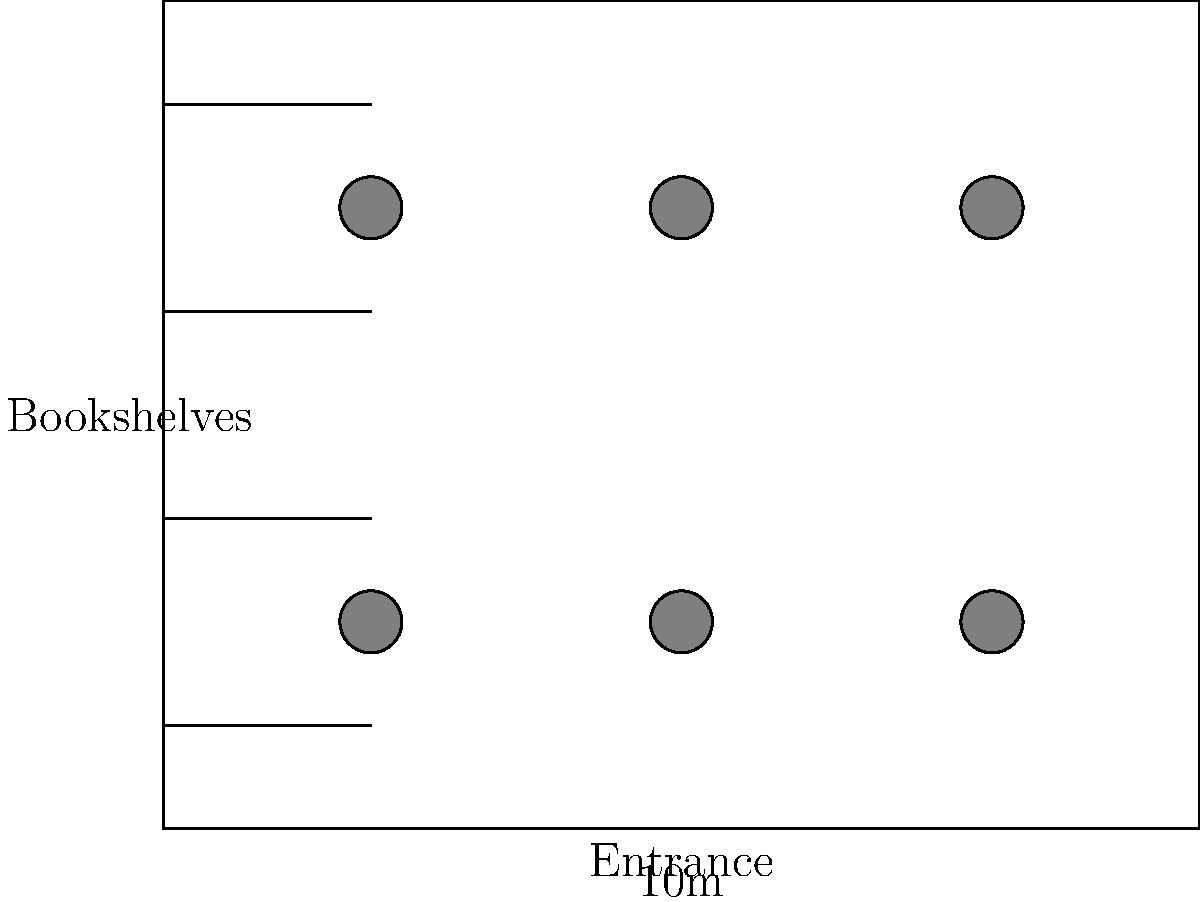In the floor plan of a community center reading room shown above, what is the maximum number of reading tables that can be accommodated while maintaining adequate space for movement? To determine the maximum number of reading tables in the community center reading room, let's analyze the floor plan step-by-step:

1. Observe the room dimensions:
   - The room is $10$ meters wide and $8$ meters long.

2. Note the existing features:
   - Bookshelves are placed along the left wall.
   - The entrance is centered on the bottom wall.

3. Analyze the current table arrangement:
   - The floor plan shows $6$ circular tables arranged in a $3 \times 2$ grid.
   - This arrangement leaves space for movement between tables and around the room's perimeter.

4. Consider space requirements:
   - Each table needs sufficient space around it for chairs and movement.
   - The current arrangement appears to maximize the use of space while maintaining functionality.

5. Evaluate potential for additional tables:
   - Adding more tables would likely crowd the space, making it difficult for children to move around comfortably.
   - The current arrangement allows for easy access to bookshelves and the entrance.

6. Consider the purpose of the room:
   - As a reading room for underprivileged children, it's important to maintain a comfortable and inviting space.
   - Overcrowding with tables could detract from the room's purpose and appeal.

Given these considerations, the maximum number of reading tables that can be accommodated while maintaining adequate space for movement is $6$, as shown in the current floor plan.
Answer: 6 tables 